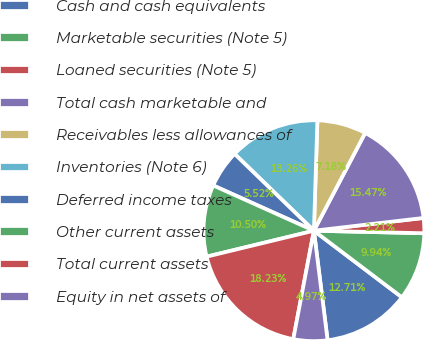<chart> <loc_0><loc_0><loc_500><loc_500><pie_chart><fcel>Cash and cash equivalents<fcel>Marketable securities (Note 5)<fcel>Loaned securities (Note 5)<fcel>Total cash marketable and<fcel>Receivables less allowances of<fcel>Inventories (Note 6)<fcel>Deferred income taxes<fcel>Other current assets<fcel>Total current assets<fcel>Equity in net assets of<nl><fcel>12.71%<fcel>9.94%<fcel>2.21%<fcel>15.47%<fcel>7.18%<fcel>13.26%<fcel>5.52%<fcel>10.5%<fcel>18.23%<fcel>4.97%<nl></chart> 